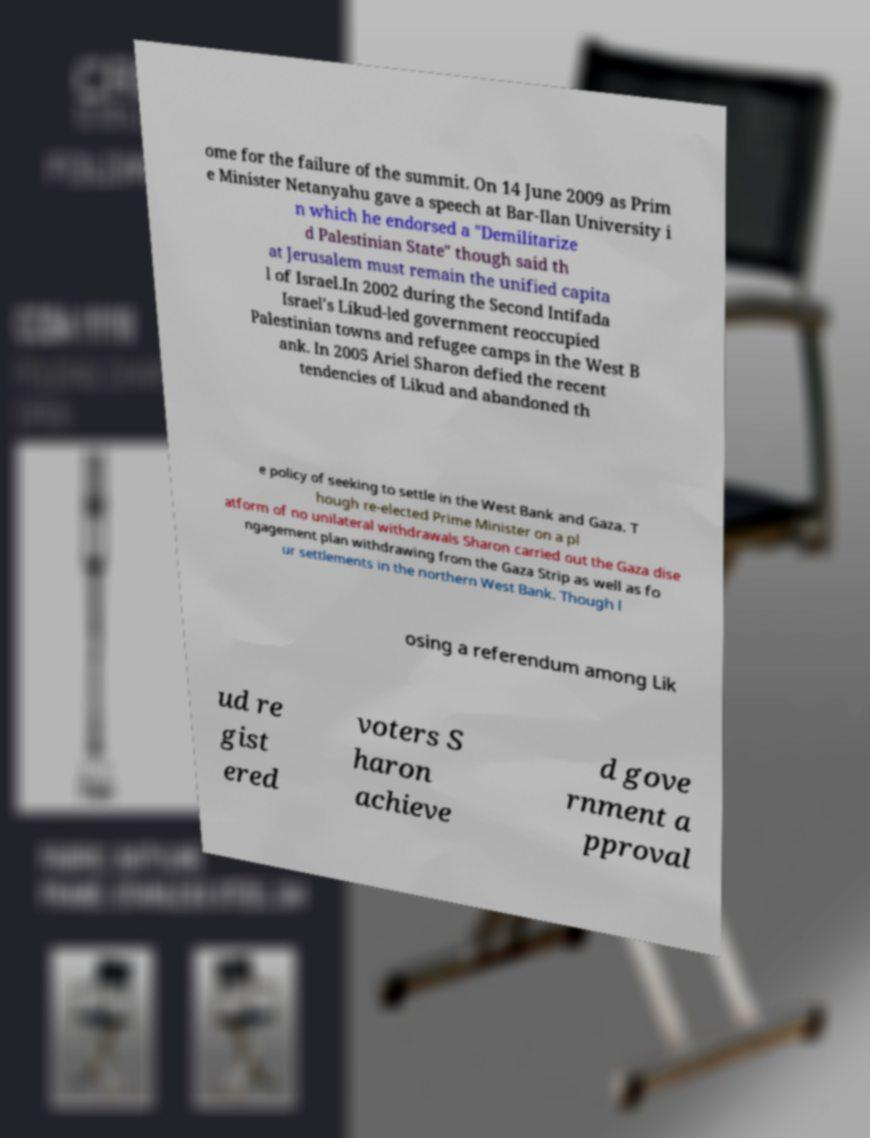Could you assist in decoding the text presented in this image and type it out clearly? ome for the failure of the summit. On 14 June 2009 as Prim e Minister Netanyahu gave a speech at Bar-Ilan University i n which he endorsed a "Demilitarize d Palestinian State" though said th at Jerusalem must remain the unified capita l of Israel.In 2002 during the Second Intifada Israel's Likud-led government reoccupied Palestinian towns and refugee camps in the West B ank. In 2005 Ariel Sharon defied the recent tendencies of Likud and abandoned th e policy of seeking to settle in the West Bank and Gaza. T hough re-elected Prime Minister on a pl atform of no unilateral withdrawals Sharon carried out the Gaza dise ngagement plan withdrawing from the Gaza Strip as well as fo ur settlements in the northern West Bank. Though l osing a referendum among Lik ud re gist ered voters S haron achieve d gove rnment a pproval 